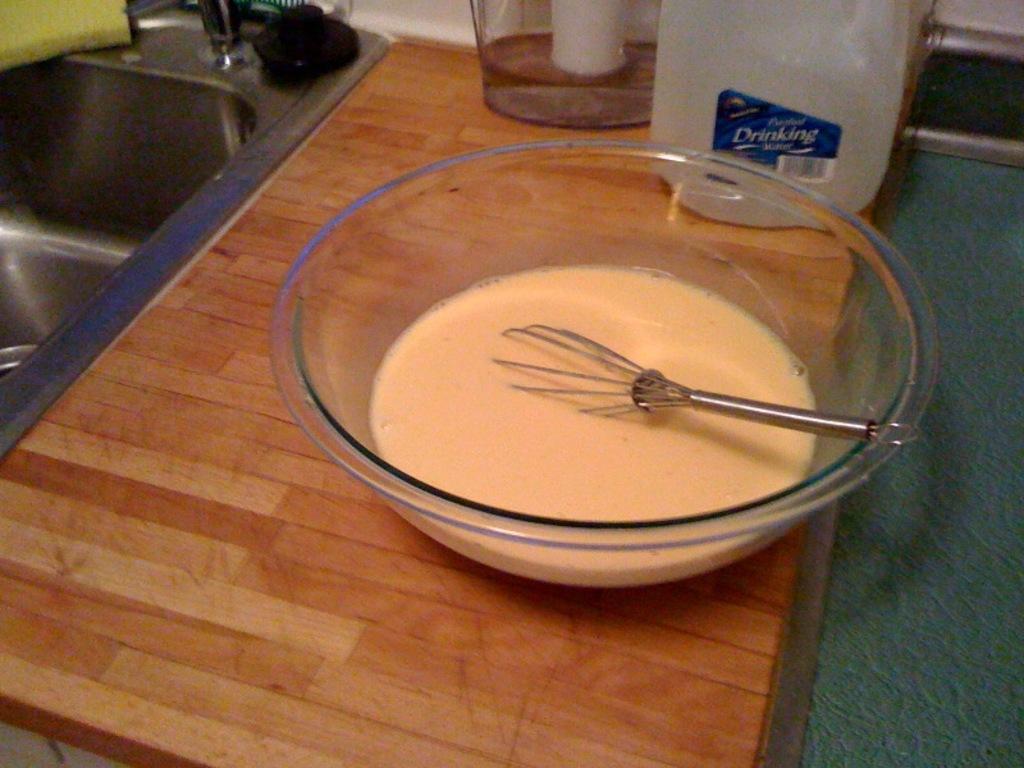Could you give a brief overview of what you see in this image? In this picture, there is a bowl placed on the table. In the bowl there is some liquid and a whisk. On the top, there is a bottle and a jar. Towards the left, there is a sink. 